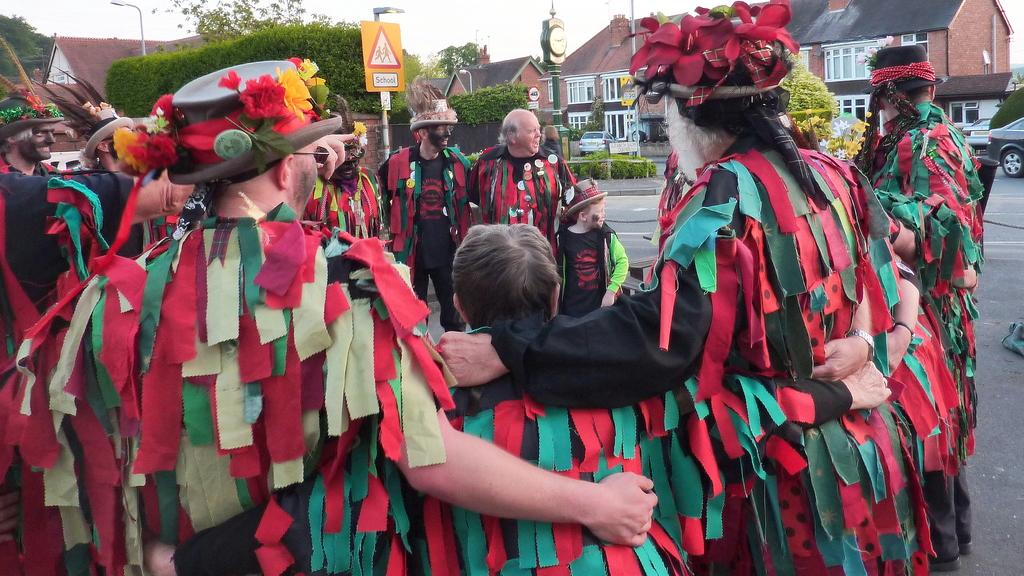What is happening on the road in the image? There is a group of people on the road in the image. What can be seen in the background of the image? Houses, trees, plants, poles, a sign board, a clock, vehicles, walls, windows, roads, and the sky are visible in the background. How many yokes are being carried by the group in the image? There are no yokes visible in the image; the group of people is on the road without any yokes. What type of footwear are the people wearing in the image? The image does not show the feet or footwear of the people, so it cannot be determined from the image. 